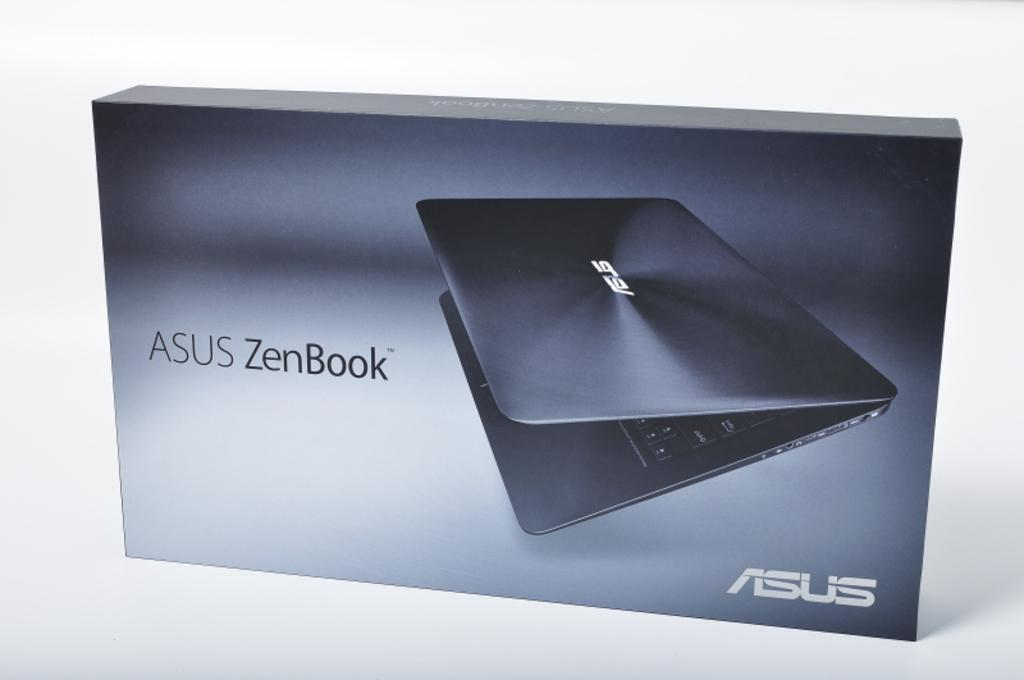<image>
Render a clear and concise summary of the photo. A box containing an ASUS ZenBook laptop stands against a white background. 